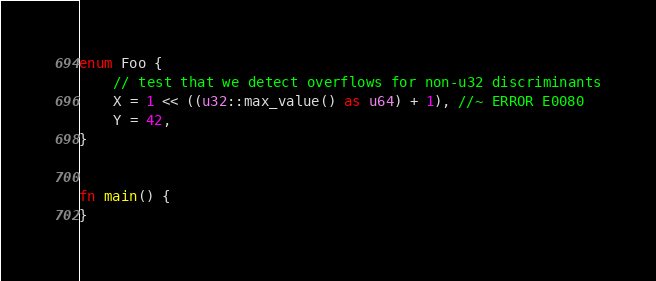<code> <loc_0><loc_0><loc_500><loc_500><_Rust_>enum Foo {
    // test that we detect overflows for non-u32 discriminants
    X = 1 << ((u32::max_value() as u64) + 1), //~ ERROR E0080
    Y = 42,
}


fn main() {
}
</code> 